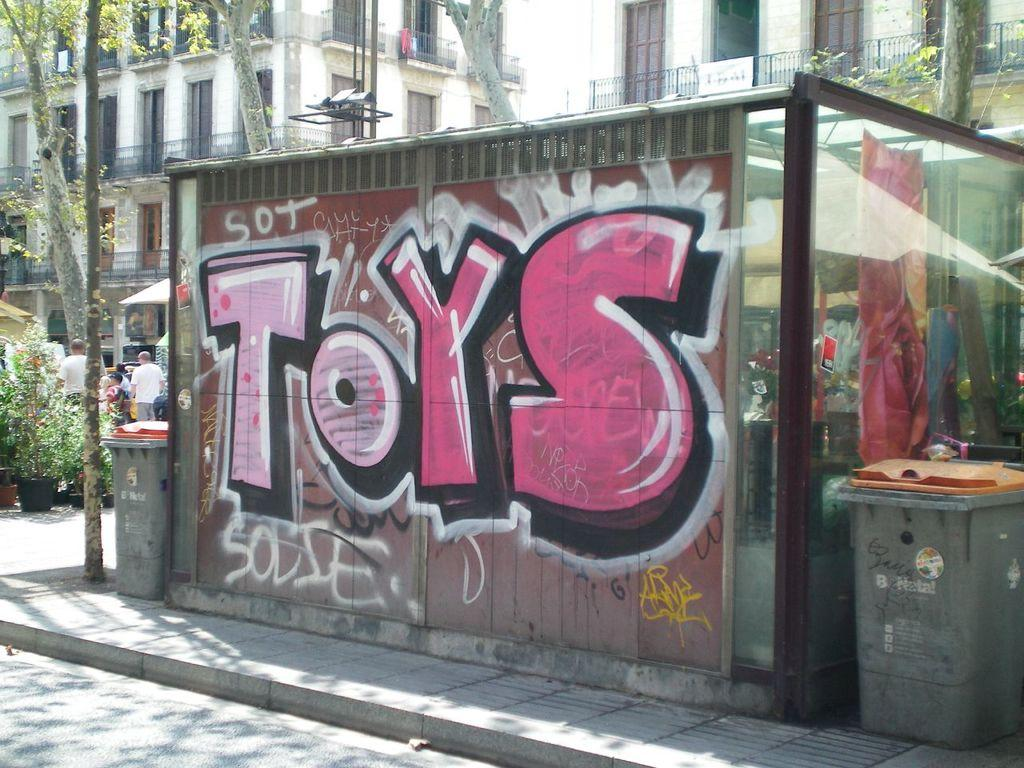<image>
Share a concise interpretation of the image provided. the word toys on the side of a wall 